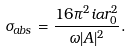<formula> <loc_0><loc_0><loc_500><loc_500>\sigma _ { a b s } = \frac { 1 6 \pi ^ { 2 } i \alpha r _ { 0 } ^ { 2 } } { \omega | A | ^ { 2 } } .</formula> 